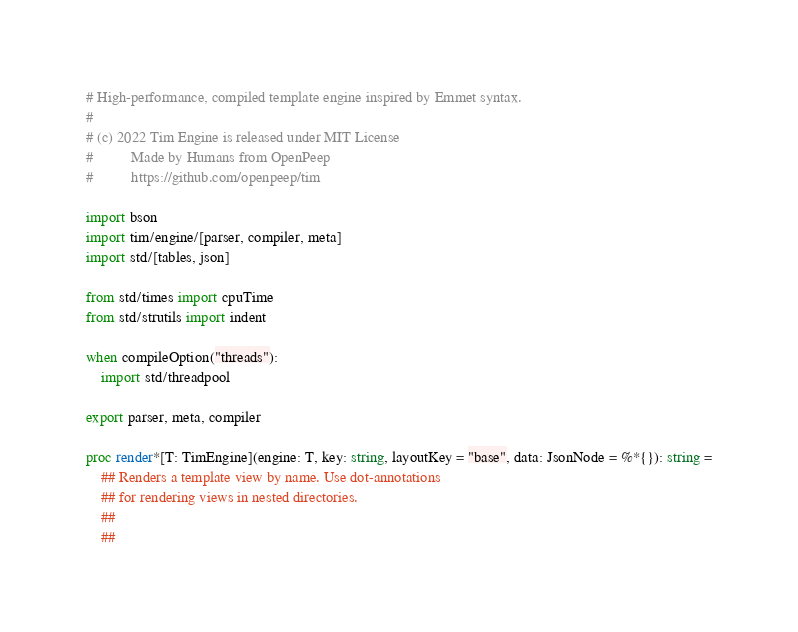<code> <loc_0><loc_0><loc_500><loc_500><_Nim_># High-performance, compiled template engine inspired by Emmet syntax.
#
# (c) 2022 Tim Engine is released under MIT License
#          Made by Humans from OpenPeep
#          https://github.com/openpeep/tim

import bson
import tim/engine/[parser, compiler, meta]
import std/[tables, json]

from std/times import cpuTime
from std/strutils import indent

when compileOption("threads"):
    import std/threadpool

export parser, meta, compiler

proc render*[T: TimEngine](engine: T, key: string, layoutKey = "base", data: JsonNode = %*{}): string =
    ## Renders a template view by name. Use dot-annotations
    ## for rendering views in nested directories.
    ##
    ##</code> 